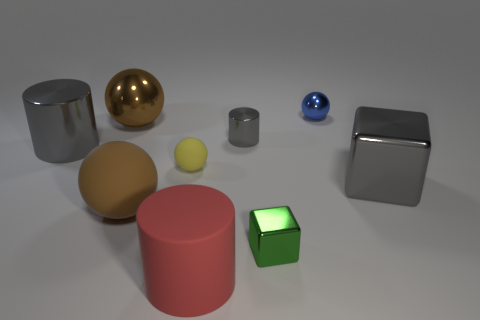Subtract 1 spheres. How many spheres are left? 3 Subtract all green spheres. Subtract all purple blocks. How many spheres are left? 4 Add 1 big green blocks. How many objects exist? 10 Subtract all cylinders. How many objects are left? 6 Add 2 big gray shiny cylinders. How many big gray shiny cylinders are left? 3 Add 8 small yellow matte balls. How many small yellow matte balls exist? 9 Subtract 0 purple cylinders. How many objects are left? 9 Subtract all blue balls. Subtract all large brown matte things. How many objects are left? 7 